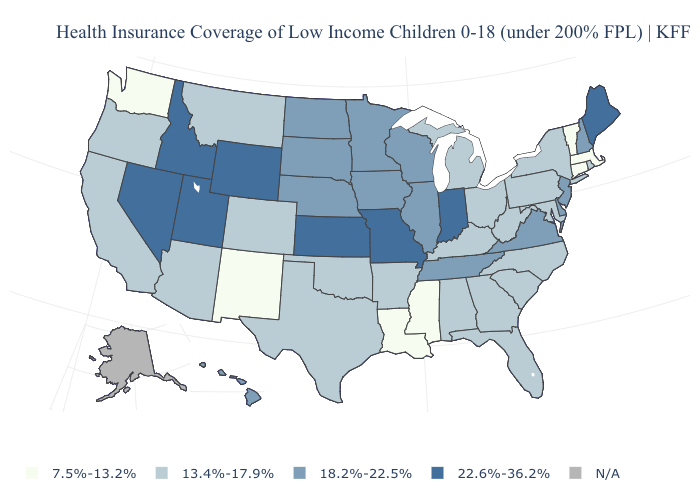What is the lowest value in states that border New Hampshire?
Write a very short answer. 7.5%-13.2%. How many symbols are there in the legend?
Give a very brief answer. 5. Among the states that border Connecticut , which have the lowest value?
Be succinct. Massachusetts. Does New Hampshire have the highest value in the USA?
Keep it brief. No. Among the states that border South Carolina , which have the highest value?
Be succinct. Georgia, North Carolina. Does New Jersey have the highest value in the Northeast?
Write a very short answer. No. What is the value of Nebraska?
Write a very short answer. 18.2%-22.5%. What is the lowest value in the USA?
Quick response, please. 7.5%-13.2%. What is the lowest value in states that border New Mexico?
Quick response, please. 13.4%-17.9%. What is the lowest value in states that border Pennsylvania?
Answer briefly. 13.4%-17.9%. What is the value of New Hampshire?
Quick response, please. 18.2%-22.5%. Does the map have missing data?
Write a very short answer. Yes. 